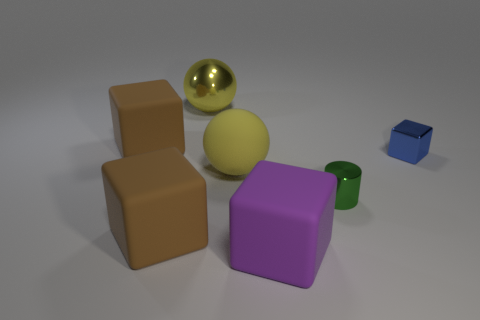Add 1 small blue cubes. How many objects exist? 8 Subtract all big blocks. How many blocks are left? 1 Subtract all blue cubes. How many cubes are left? 3 Add 2 brown matte objects. How many brown matte objects are left? 4 Add 7 yellow metallic spheres. How many yellow metallic spheres exist? 8 Subtract 1 green cylinders. How many objects are left? 6 Subtract all blocks. How many objects are left? 3 Subtract 1 spheres. How many spheres are left? 1 Subtract all yellow cylinders. Subtract all brown cubes. How many cylinders are left? 1 Subtract all purple spheres. How many brown blocks are left? 2 